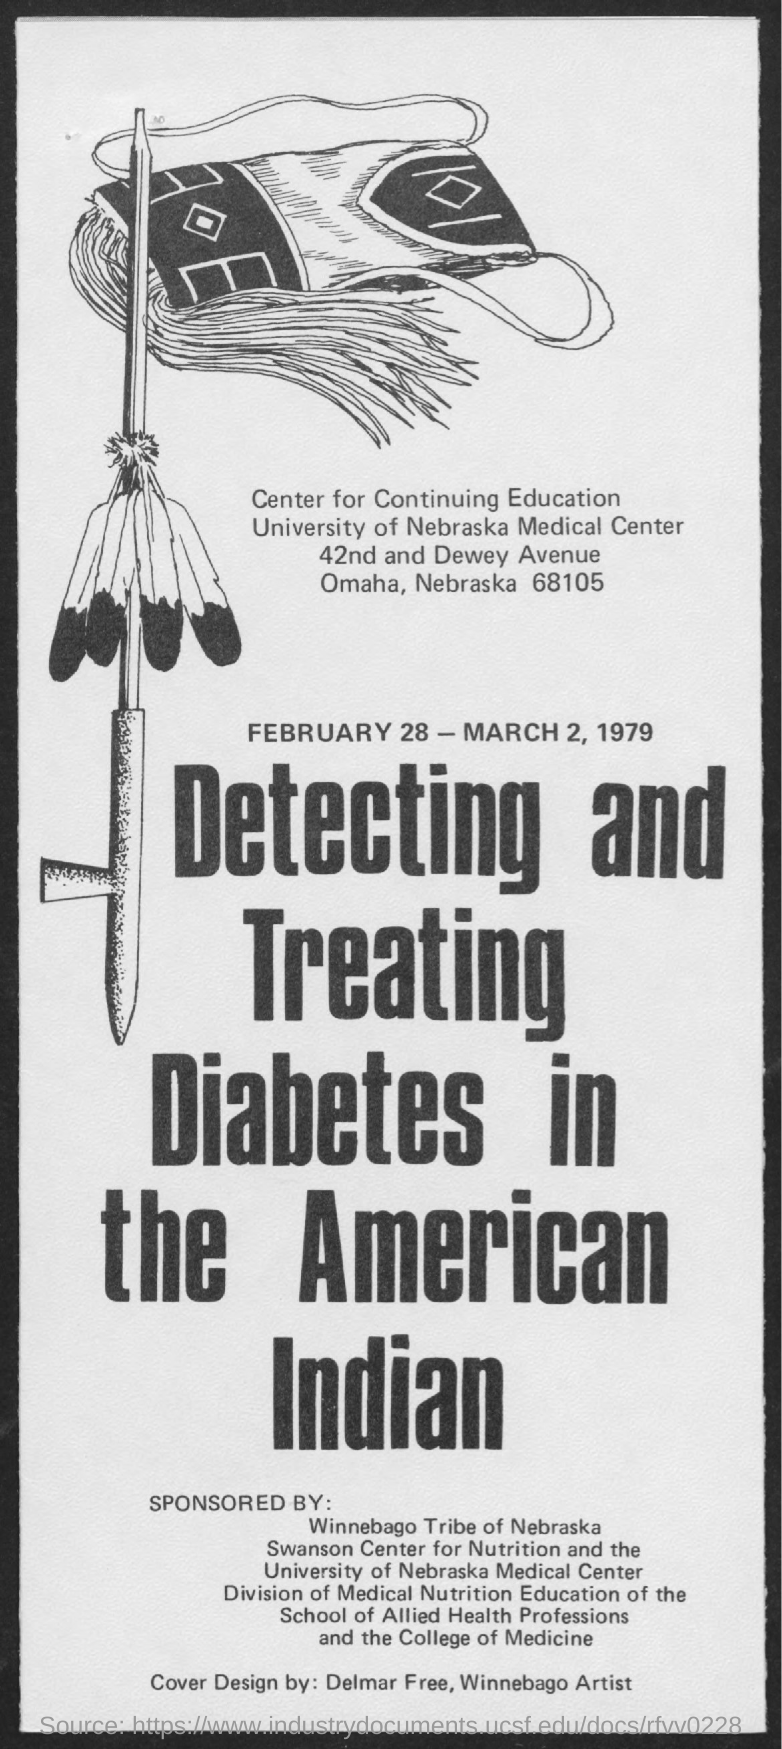Outline some significant characteristics in this image. The designer of the cover is Delmar Free, a Winnebago artist. I, [Your Name], declare that the dates of the program were February 28 - March 2, 1979. 